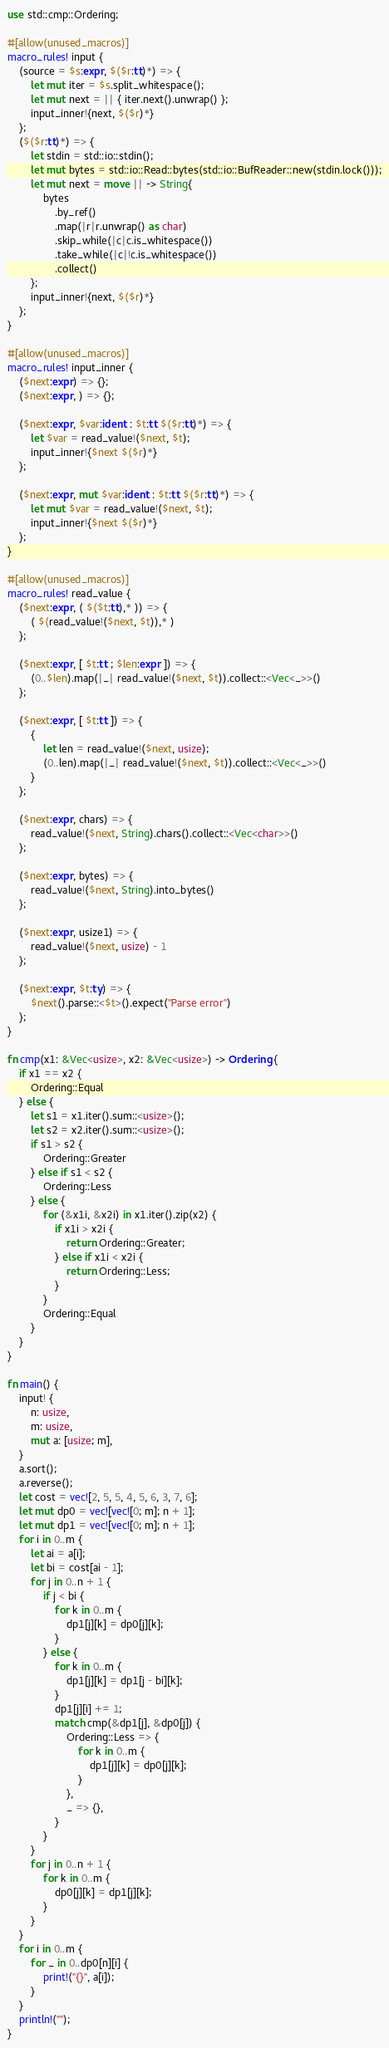Convert code to text. <code><loc_0><loc_0><loc_500><loc_500><_Rust_>use std::cmp::Ordering;

#[allow(unused_macros)]
macro_rules! input {
    (source = $s:expr, $($r:tt)*) => {
        let mut iter = $s.split_whitespace();
        let mut next = || { iter.next().unwrap() };
        input_inner!{next, $($r)*}
    };
    ($($r:tt)*) => {
        let stdin = std::io::stdin();
        let mut bytes = std::io::Read::bytes(std::io::BufReader::new(stdin.lock()));
        let mut next = move || -> String{
            bytes
                .by_ref()
                .map(|r|r.unwrap() as char)
                .skip_while(|c|c.is_whitespace())
                .take_while(|c|!c.is_whitespace())
                .collect()
        };
        input_inner!{next, $($r)*}
    };
}

#[allow(unused_macros)]
macro_rules! input_inner {
    ($next:expr) => {};
    ($next:expr, ) => {};

    ($next:expr, $var:ident : $t:tt $($r:tt)*) => {
        let $var = read_value!($next, $t);
        input_inner!{$next $($r)*}
    };

    ($next:expr, mut $var:ident : $t:tt $($r:tt)*) => {
        let mut $var = read_value!($next, $t);
        input_inner!{$next $($r)*}
    };
}

#[allow(unused_macros)]
macro_rules! read_value {
    ($next:expr, ( $($t:tt),* )) => {
        ( $(read_value!($next, $t)),* )
    };

    ($next:expr, [ $t:tt ; $len:expr ]) => {
        (0..$len).map(|_| read_value!($next, $t)).collect::<Vec<_>>()
    };

    ($next:expr, [ $t:tt ]) => {
        {
            let len = read_value!($next, usize);
            (0..len).map(|_| read_value!($next, $t)).collect::<Vec<_>>()
        }
    };

    ($next:expr, chars) => {
        read_value!($next, String).chars().collect::<Vec<char>>()
    };

    ($next:expr, bytes) => {
        read_value!($next, String).into_bytes()
    };

    ($next:expr, usize1) => {
        read_value!($next, usize) - 1
    };

    ($next:expr, $t:ty) => {
        $next().parse::<$t>().expect("Parse error")
    };
}

fn cmp(x1: &Vec<usize>, x2: &Vec<usize>) -> Ordering {
    if x1 == x2 {
        Ordering::Equal
    } else {
        let s1 = x1.iter().sum::<usize>();
        let s2 = x2.iter().sum::<usize>();
        if s1 > s2 {
            Ordering::Greater
        } else if s1 < s2 {
            Ordering::Less
        } else {
            for (&x1i, &x2i) in x1.iter().zip(x2) {
                if x1i > x2i {
                    return Ordering::Greater;
                } else if x1i < x2i {
                    return Ordering::Less;
                }
            }
            Ordering::Equal
        }
    }
}

fn main() {
    input! {
        n: usize,
        m: usize,
        mut a: [usize; m],
    }
    a.sort();
    a.reverse();
    let cost = vec![2, 5, 5, 4, 5, 6, 3, 7, 6];
    let mut dp0 = vec![vec![0; m]; n + 1];
    let mut dp1 = vec![vec![0; m]; n + 1];
    for i in 0..m {
        let ai = a[i];
        let bi = cost[ai - 1];
        for j in 0..n + 1 {
            if j < bi {
                for k in 0..m {
                    dp1[j][k] = dp0[j][k];
                }
            } else {
                for k in 0..m {
                    dp1[j][k] = dp1[j - bi][k];
                }
                dp1[j][i] += 1;
                match cmp(&dp1[j], &dp0[j]) {
                    Ordering::Less => {
                        for k in 0..m {
                            dp1[j][k] = dp0[j][k];
                        }
                    },
                    _ => {},
                }
            }
        }
        for j in 0..n + 1 {
            for k in 0..m {
                dp0[j][k] = dp1[j][k];
            }
        }
    }
    for i in 0..m {
        for _ in 0..dp0[n][i] {
            print!("{}", a[i]);
        }
    }
    println!("");
}
</code> 